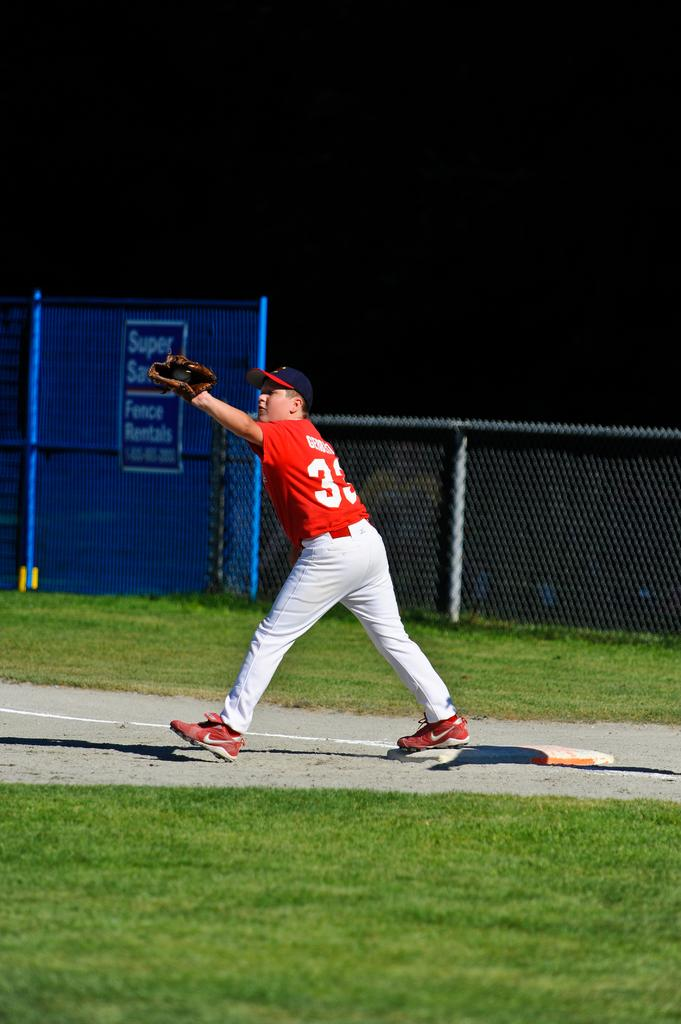<image>
Give a short and clear explanation of the subsequent image. Baseball player number 33 caught the ball in front of the Fence Rentals sign. 